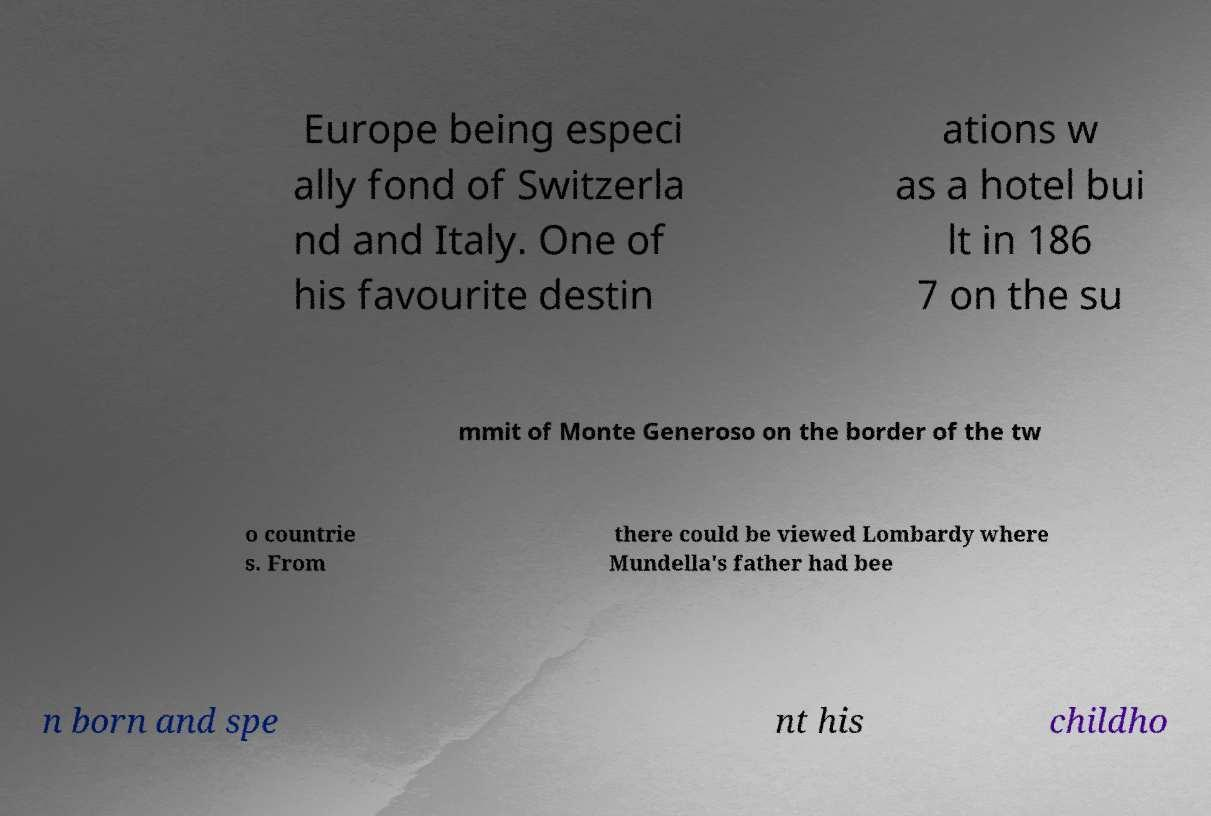For documentation purposes, I need the text within this image transcribed. Could you provide that? Europe being especi ally fond of Switzerla nd and Italy. One of his favourite destin ations w as a hotel bui lt in 186 7 on the su mmit of Monte Generoso on the border of the tw o countrie s. From there could be viewed Lombardy where Mundella's father had bee n born and spe nt his childho 